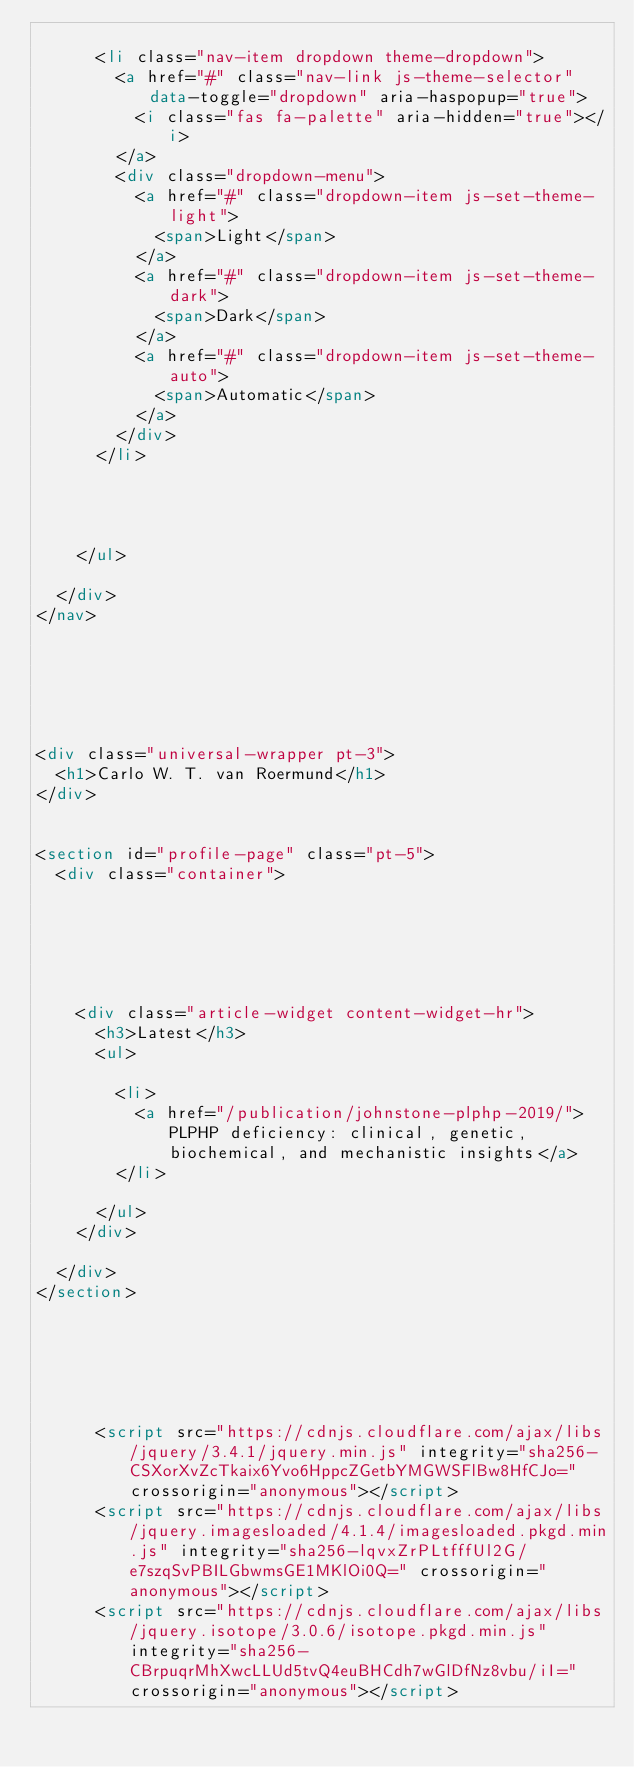<code> <loc_0><loc_0><loc_500><loc_500><_HTML_>      
      <li class="nav-item dropdown theme-dropdown">
        <a href="#" class="nav-link js-theme-selector" data-toggle="dropdown" aria-haspopup="true">
          <i class="fas fa-palette" aria-hidden="true"></i>
        </a>
        <div class="dropdown-menu">
          <a href="#" class="dropdown-item js-set-theme-light">
            <span>Light</span>
          </a>
          <a href="#" class="dropdown-item js-set-theme-dark">
            <span>Dark</span>
          </a>
          <a href="#" class="dropdown-item js-set-theme-auto">
            <span>Automatic</span>
          </a>
        </div>
      </li>
      

      

    </ul>

  </div>
</nav>


  



<div class="universal-wrapper pt-3">
  <h1>Carlo W. T. van Roermund</h1>
</div>


<section id="profile-page" class="pt-5">
  <div class="container">
    
    

    
    
    
    <div class="article-widget content-widget-hr">
      <h3>Latest</h3>
      <ul>
        
        <li>
          <a href="/publication/johnstone-plphp-2019/">PLPHP deficiency: clinical, genetic, biochemical, and mechanistic insights</a>
        </li>
        
      </ul>
    </div>
    
  </div>
</section>

      

    
    
    
      <script src="https://cdnjs.cloudflare.com/ajax/libs/jquery/3.4.1/jquery.min.js" integrity="sha256-CSXorXvZcTkaix6Yvo6HppcZGetbYMGWSFlBw8HfCJo=" crossorigin="anonymous"></script>
      <script src="https://cdnjs.cloudflare.com/ajax/libs/jquery.imagesloaded/4.1.4/imagesloaded.pkgd.min.js" integrity="sha256-lqvxZrPLtfffUl2G/e7szqSvPBILGbwmsGE1MKlOi0Q=" crossorigin="anonymous"></script>
      <script src="https://cdnjs.cloudflare.com/ajax/libs/jquery.isotope/3.0.6/isotope.pkgd.min.js" integrity="sha256-CBrpuqrMhXwcLLUd5tvQ4euBHCdh7wGlDfNz8vbu/iI=" crossorigin="anonymous"></script></code> 